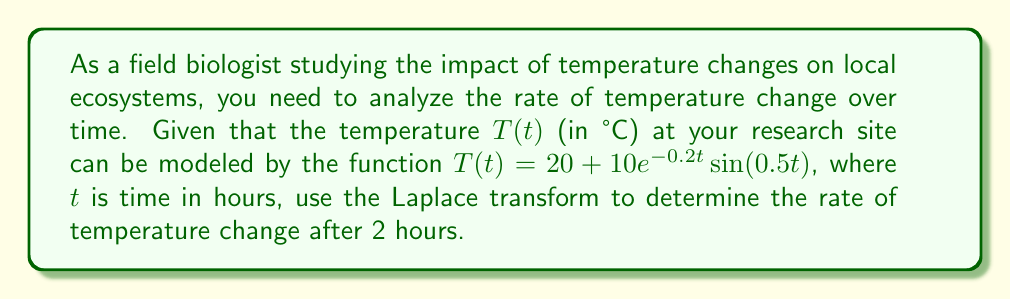Solve this math problem. To solve this problem, we'll follow these steps:

1) First, we need to find the Laplace transform of $T(t)$:
   
   $$\mathcal{L}\{T(t)\} = \mathcal{L}\{20 + 10e^{-0.2t} \sin(0.5t)\}$$

2) Using linearity and the shift property of Laplace transforms:
   
   $$\mathcal{L}\{T(t)\} = \frac{20}{s} + 10\mathcal{L}\{e^{-0.2t} \sin(0.5t)\}$$

3) The Laplace transform of $e^{-at} \sin(bt)$ is $\frac{b}{(s+a)^2 + b^2}$, so:
   
   $$\mathcal{L}\{T(t)\} = \frac{20}{s} + \frac{5}{(s+0.2)^2 + 0.25}$$

4) To find the rate of change, we need to differentiate $T(t)$ with respect to $t$. In the Laplace domain, this is equivalent to multiplying by $s$ and subtracting the initial value:
   
   $$\mathcal{L}\{\frac{dT}{dt}\} = s\mathcal{L}\{T(t)\} - T(0)$$
   
   $$= s(\frac{20}{s} + \frac{5}{(s+0.2)^2 + 0.25}) - 20$$
   
   $$= 20 + \frac{5s}{(s+0.2)^2 + 0.25} - 20$$
   
   $$= \frac{5s}{(s+0.2)^2 + 0.25}$$

5) To find the rate of change at $t=2$, we need to find the inverse Laplace transform and then evaluate at $t=2$:
   
   $$\frac{dT}{dt} = \mathcal{L}^{-1}\{\frac{5s}{(s+0.2)^2 + 0.25}\}$$
   
   $$= 5e^{-0.2t}(\cos(0.5t) - 0.4\sin(0.5t))$$

6) Evaluating at $t=2$:
   
   $$\frac{dT}{dt}|_{t=2} = 5e^{-0.4}(\cos(1) - 0.4\sin(1))$$
   
   $$\approx 2.7138$$

Therefore, the rate of temperature change after 2 hours is approximately 2.7138 °C/hour.
Answer: The rate of temperature change after 2 hours is approximately 2.7138 °C/hour. 